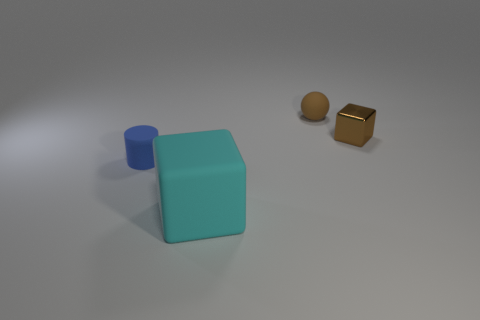Is there anything else that has the same material as the brown block?
Provide a short and direct response. No. What shape is the tiny rubber object that is in front of the brown thing that is to the right of the tiny rubber object that is behind the small blue thing?
Give a very brief answer. Cylinder. Is the number of blue things that are on the left side of the tiny blue matte thing greater than the number of metallic cubes?
Ensure brevity in your answer.  No. There is a brown matte object; is its shape the same as the object in front of the blue thing?
Ensure brevity in your answer.  No. The small rubber object that is the same color as the metallic thing is what shape?
Your response must be concise. Sphere. There is a small rubber thing that is on the left side of the matte object on the right side of the matte cube; what number of matte balls are to the left of it?
Give a very brief answer. 0. There is a sphere that is the same size as the blue rubber thing; what color is it?
Ensure brevity in your answer.  Brown. What size is the block on the left side of the small brown object that is behind the tiny brown shiny thing?
Offer a terse response. Large. The matte object that is the same color as the metallic block is what size?
Offer a terse response. Small. How many other things are the same size as the cyan block?
Ensure brevity in your answer.  0. 